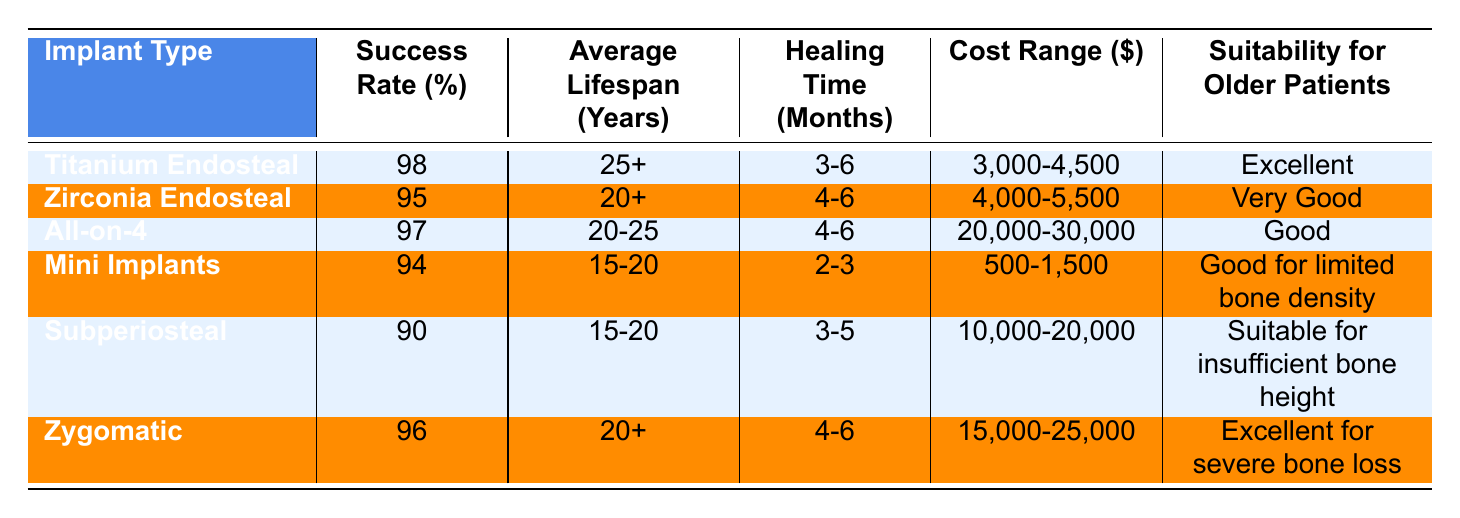What is the success rate of Titanium Endosteal implants? The table directly lists the success rate for Titanium Endosteal implants as 98%.
Answer: 98% Which implant type has the highest average lifespan? By comparing the average lifespan values in the table, Titanium Endosteal has the highest at 25+ years.
Answer: Titanium Endosteal How many months of healing time are required for Mini Implants? The table states that Mini Implants have a healing time of 2-3 months.
Answer: 2-3 months Is Zirconia Endosteal considered suitable for older patients? The table indicates that Zirconia Endosteal has a suitability rating of "Very Good" for older patients, which implies suitability.
Answer: Yes What is the cost difference between Zygomatic and All-on-4 implants? The cost range for Zygomatic implants is $15,000-$25,000 and for All-on-4 it is $20,000-$30,000. The minimum cost difference is $5,000 and the maximum is $10,000.
Answer: $5,000 to $10,000 Which implant type has the best suitability for older patients? The table shows that both Titanium Endosteal and Zygomatic implants have "Excellent" suitability for older patients, indicating they are the best options.
Answer: Titanium Endosteal and Zygomatic Are the healing times for All-on-4 and Zygomatic implants the same? Both All-on-4 and Zygomatic implants require a healing time of 4-6 months as per the table.
Answer: Yes What is the average lifespan of Mini Implants and how does it compare to the others? Mini Implants have an average lifespan of 15-20 years, which is shorter than the other types, especially Titanium Endosteal which lasts 25+ years.
Answer: Shorter than others If I wanted to know the average healing time for all implants listed, how would I calculate it? To find the average healing time, convert the time ranges to a midpoint (for instance, 3-4 for Titanium) and compute the average of these midpoints across all implants.
Answer: You need to calculate the midpoint healing times Which implant has the lowest success rate and what is that rate? Among the implants listed, Subperiosteal has the lowest success rate at 90%.
Answer: 90% 